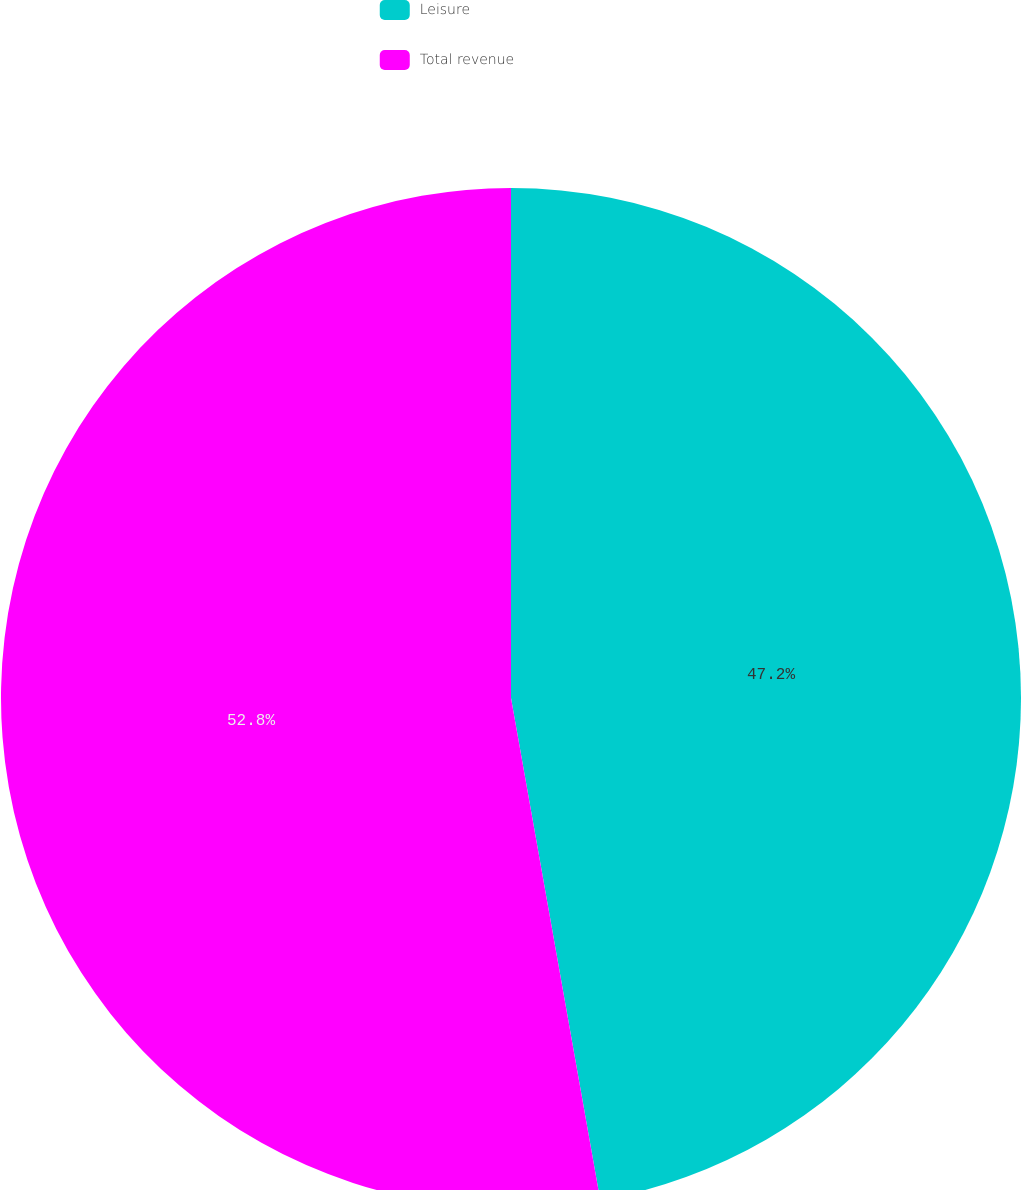Convert chart to OTSL. <chart><loc_0><loc_0><loc_500><loc_500><pie_chart><fcel>Leisure<fcel>Total revenue<nl><fcel>47.2%<fcel>52.8%<nl></chart> 